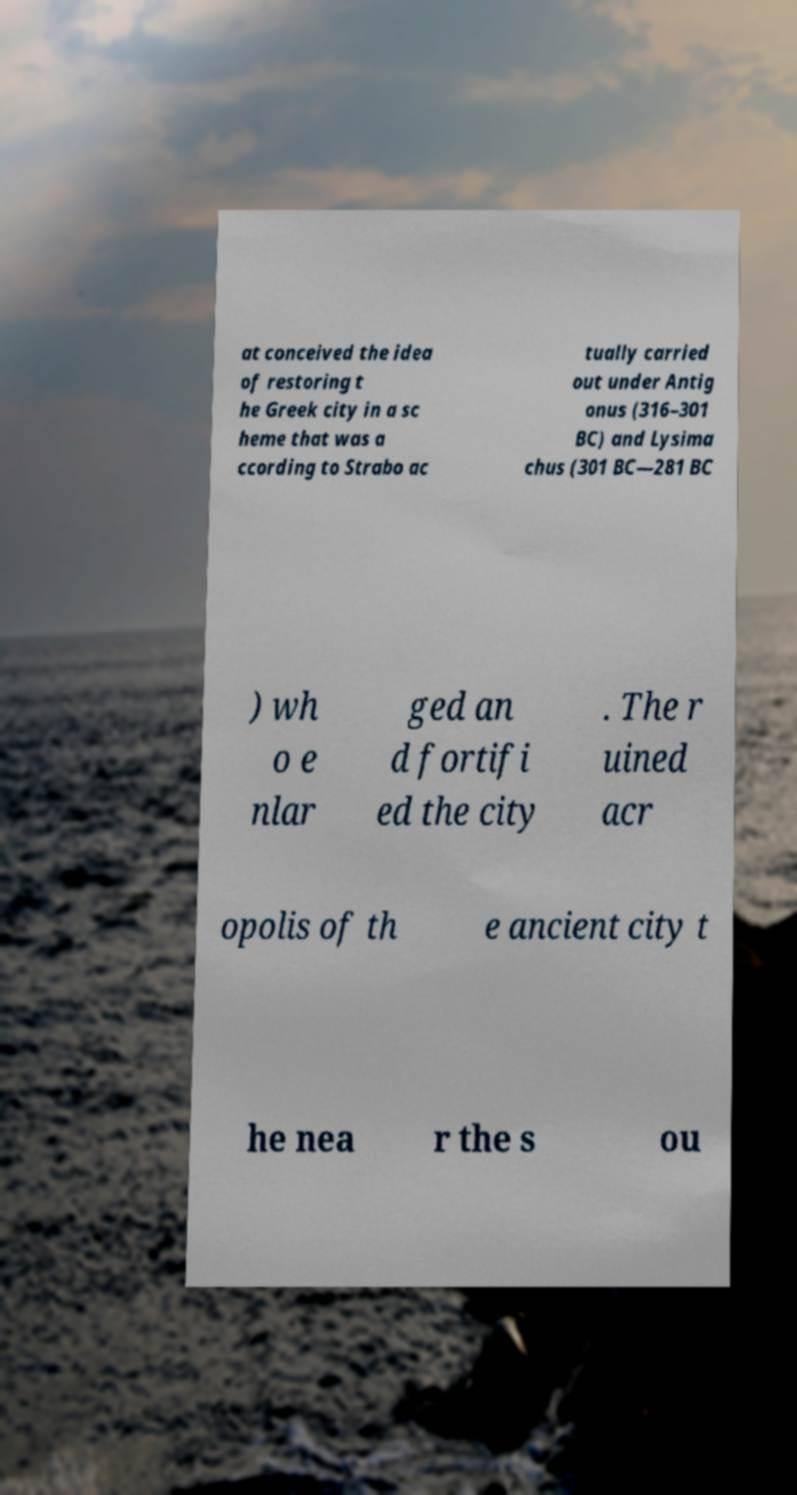I need the written content from this picture converted into text. Can you do that? at conceived the idea of restoring t he Greek city in a sc heme that was a ccording to Strabo ac tually carried out under Antig onus (316–301 BC) and Lysima chus (301 BC—281 BC ) wh o e nlar ged an d fortifi ed the city . The r uined acr opolis of th e ancient city t he nea r the s ou 